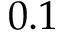Convert formula to latex. <formula><loc_0><loc_0><loc_500><loc_500>0 . 1</formula> 